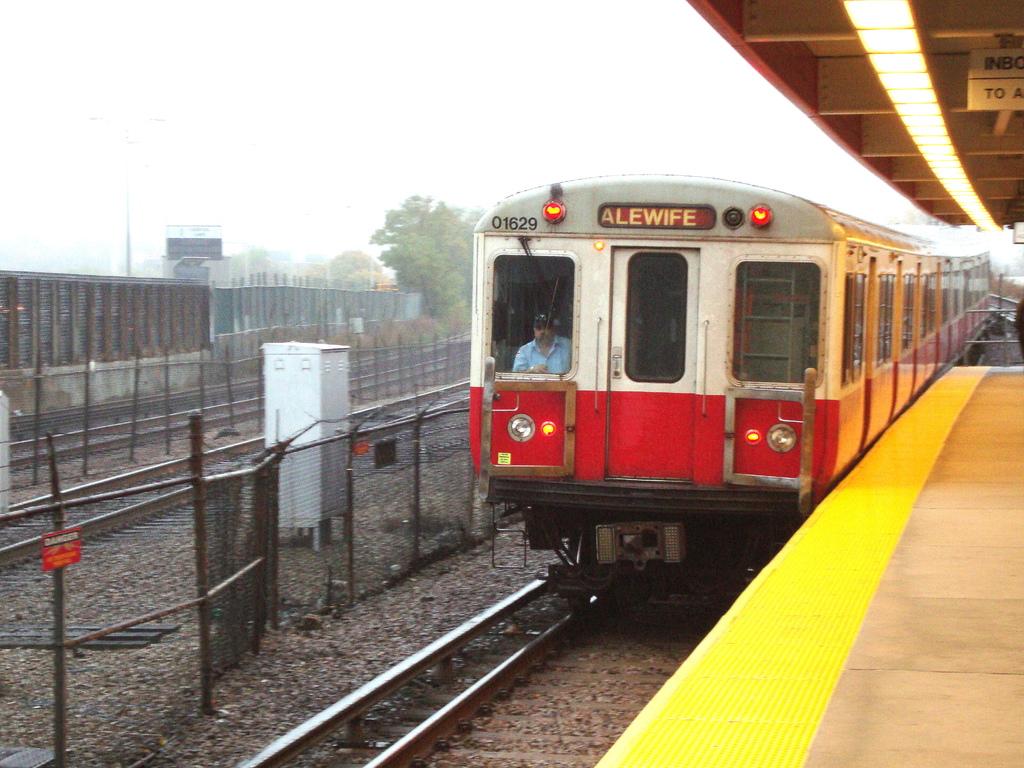What is the train number?
Keep it short and to the point. 01629. Where is the train going?
Your response must be concise. Alewife. 